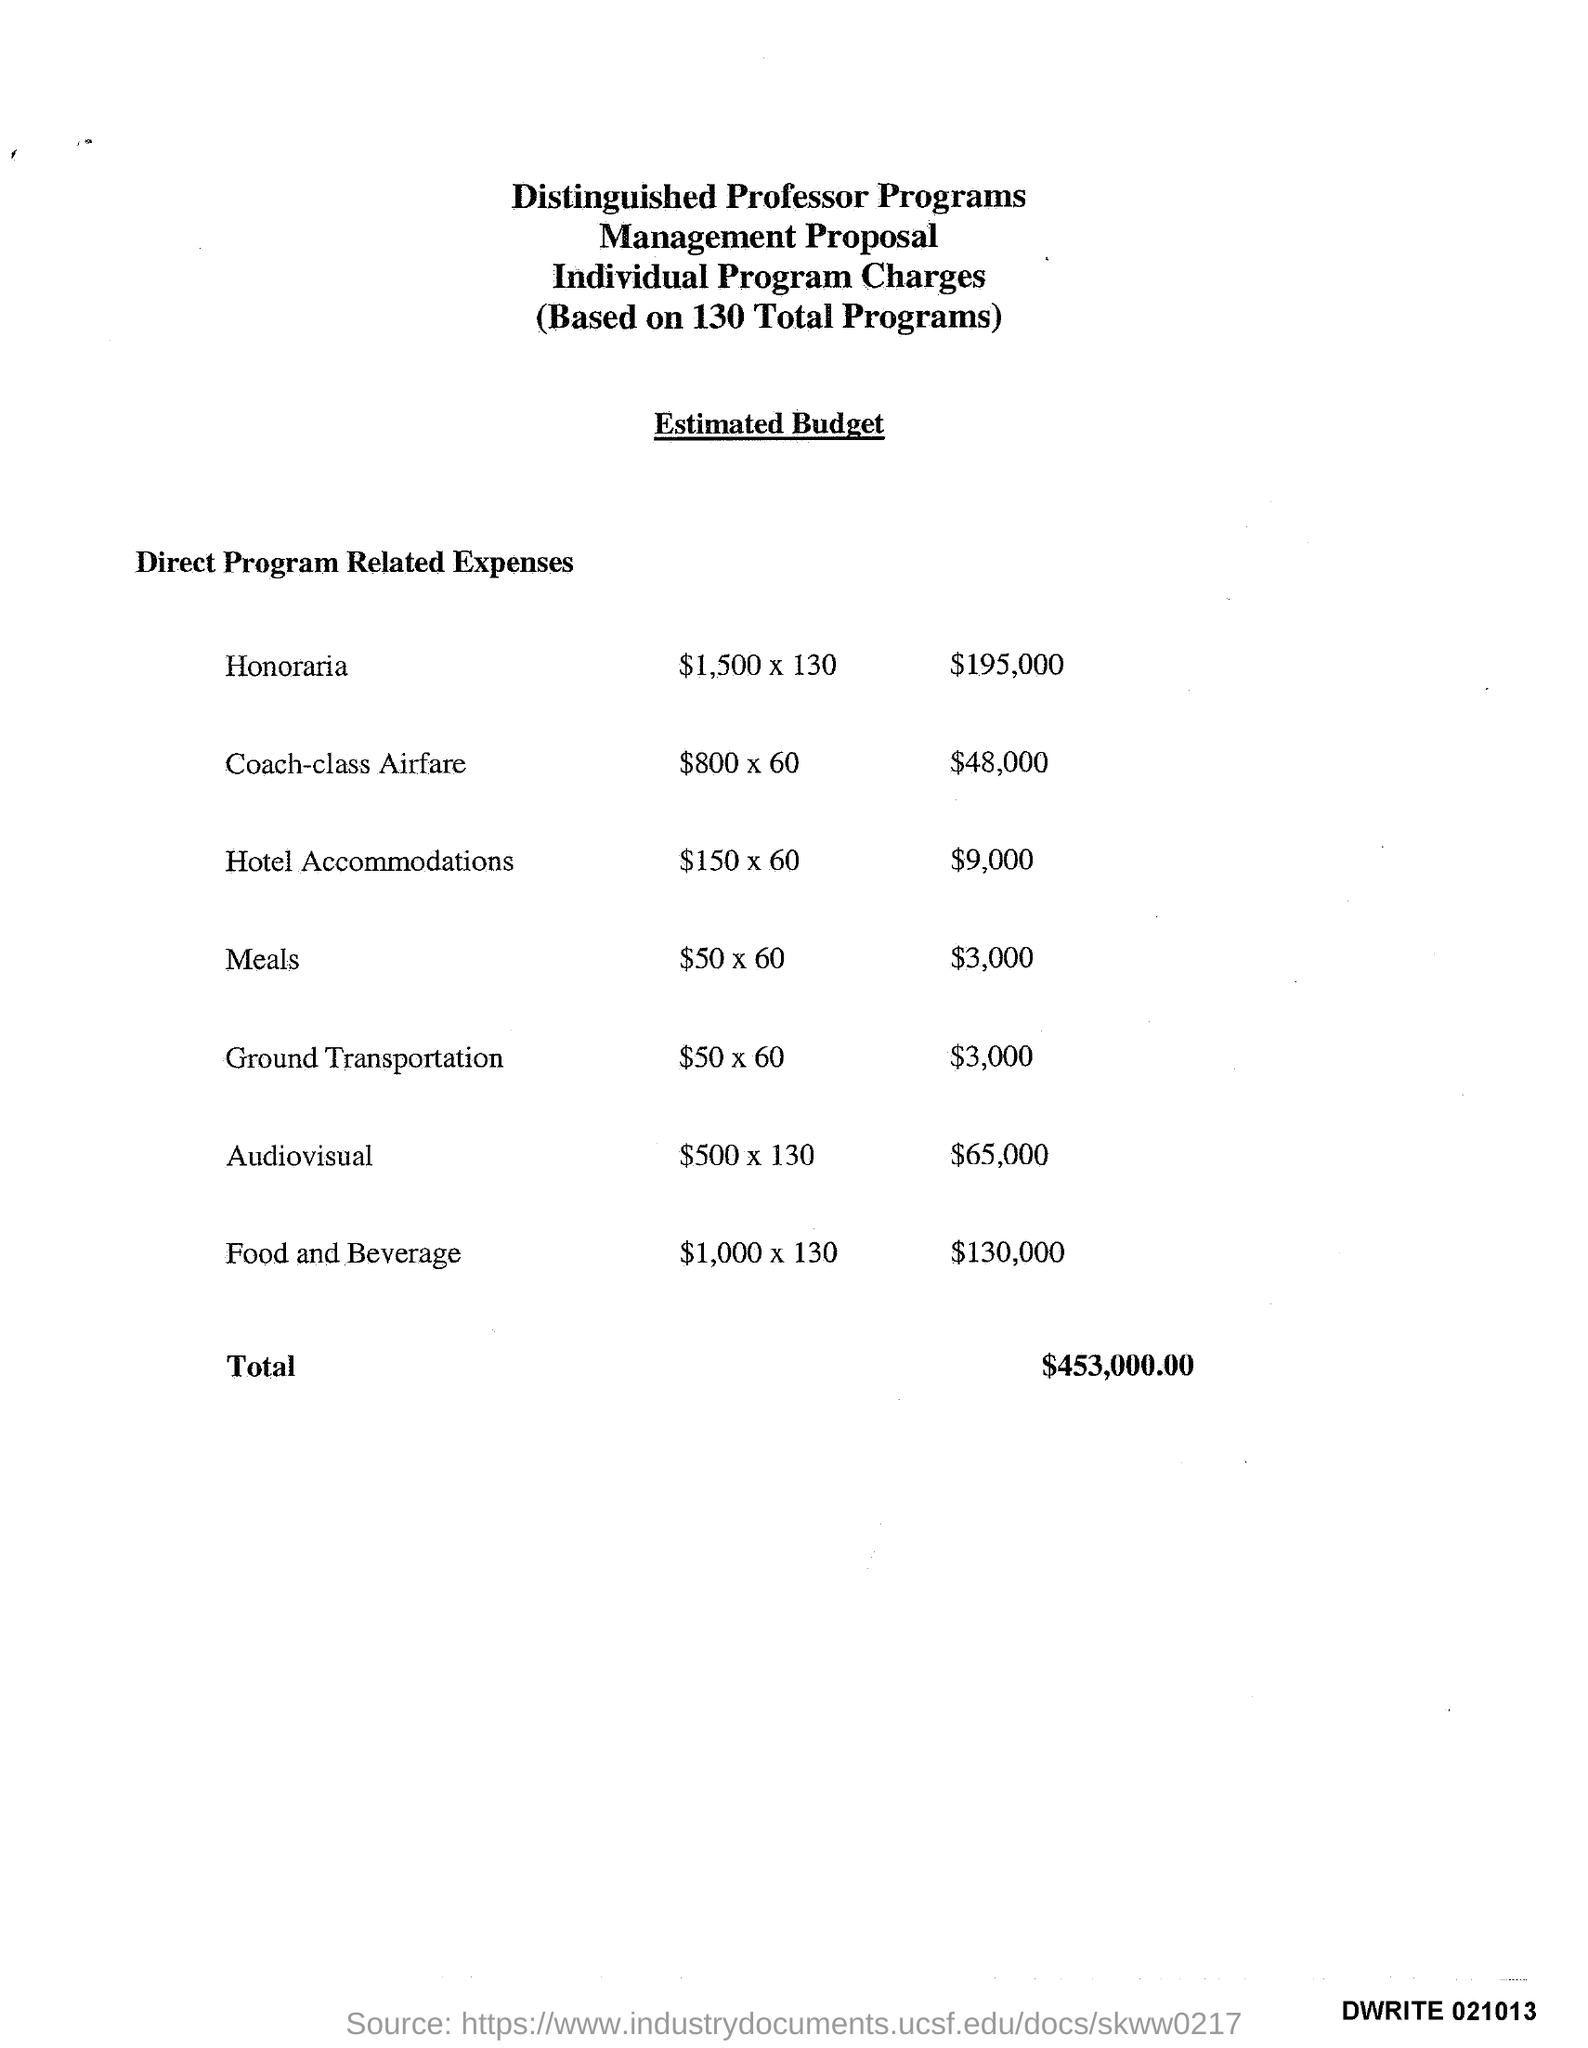What are the major cost components for the Distinguished Professor Programs as per the document? The major cost components include 'Honoraria', 'Coach-class Airfare', 'Hotel Accommodations', 'Meals', 'Ground Transportation', 'Audiovisual', and 'Food and Beverage'. The most significant expenses are 'Honoraria' and 'Food and Beverage'. Which component has the second-highest budget allocation? 'Food and Beverage' has the second-highest budget allocation with $130,000, following 'Honoraria'. 